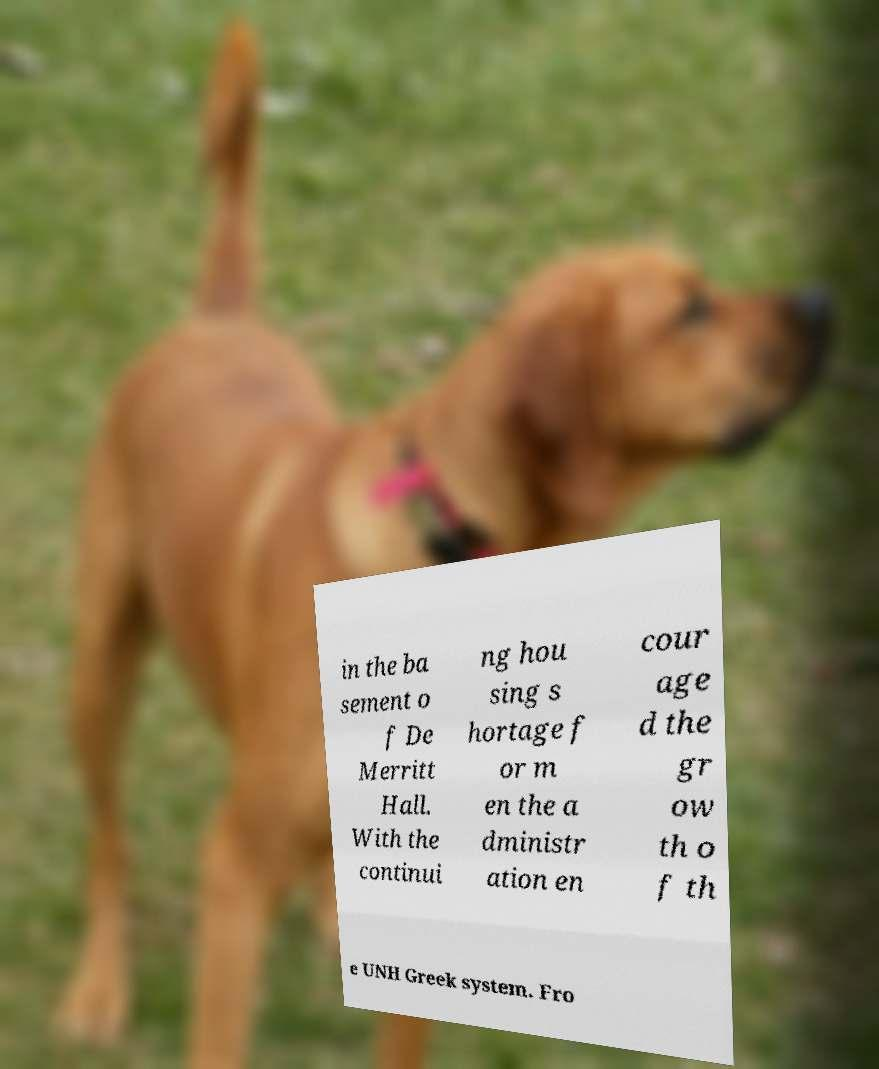Please read and relay the text visible in this image. What does it say? in the ba sement o f De Merritt Hall. With the continui ng hou sing s hortage f or m en the a dministr ation en cour age d the gr ow th o f th e UNH Greek system. Fro 